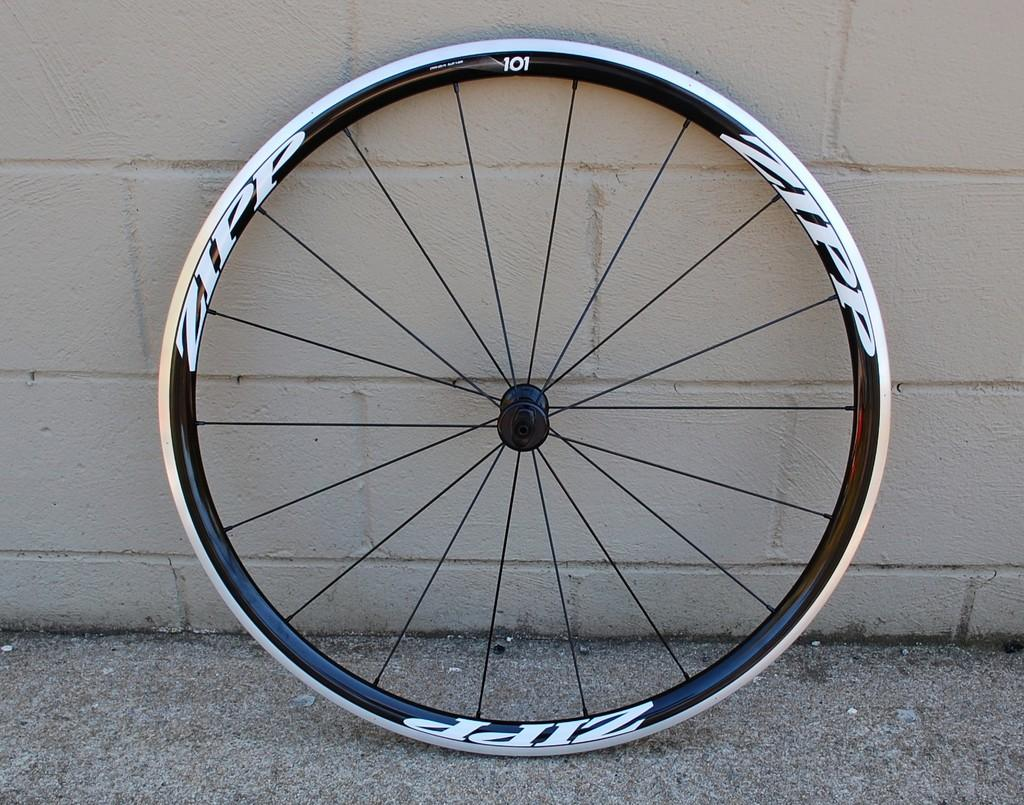Where was the picture taken? The picture was taken outside. What can be seen in the center of the image? There is a wheel placed on the ground in the center of the image. What is visible in the background of the image? There is a wall in the background of the image. How many cherries are hanging from the elbow in the image? There are no cherries or elbows present in the image. 